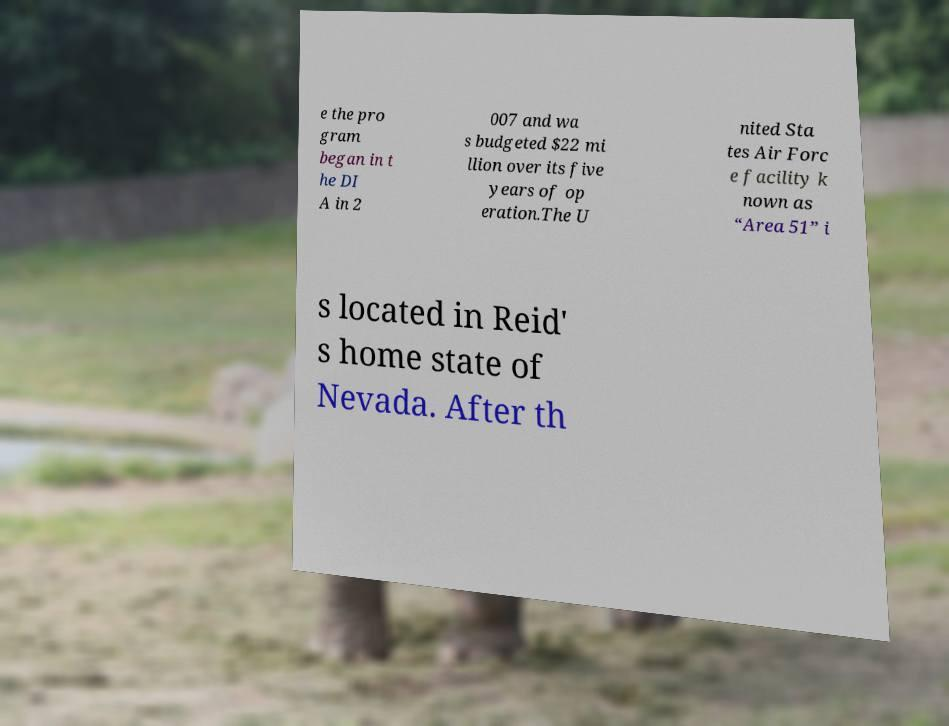Could you extract and type out the text from this image? e the pro gram began in t he DI A in 2 007 and wa s budgeted $22 mi llion over its five years of op eration.The U nited Sta tes Air Forc e facility k nown as “Area 51” i s located in Reid' s home state of Nevada. After th 